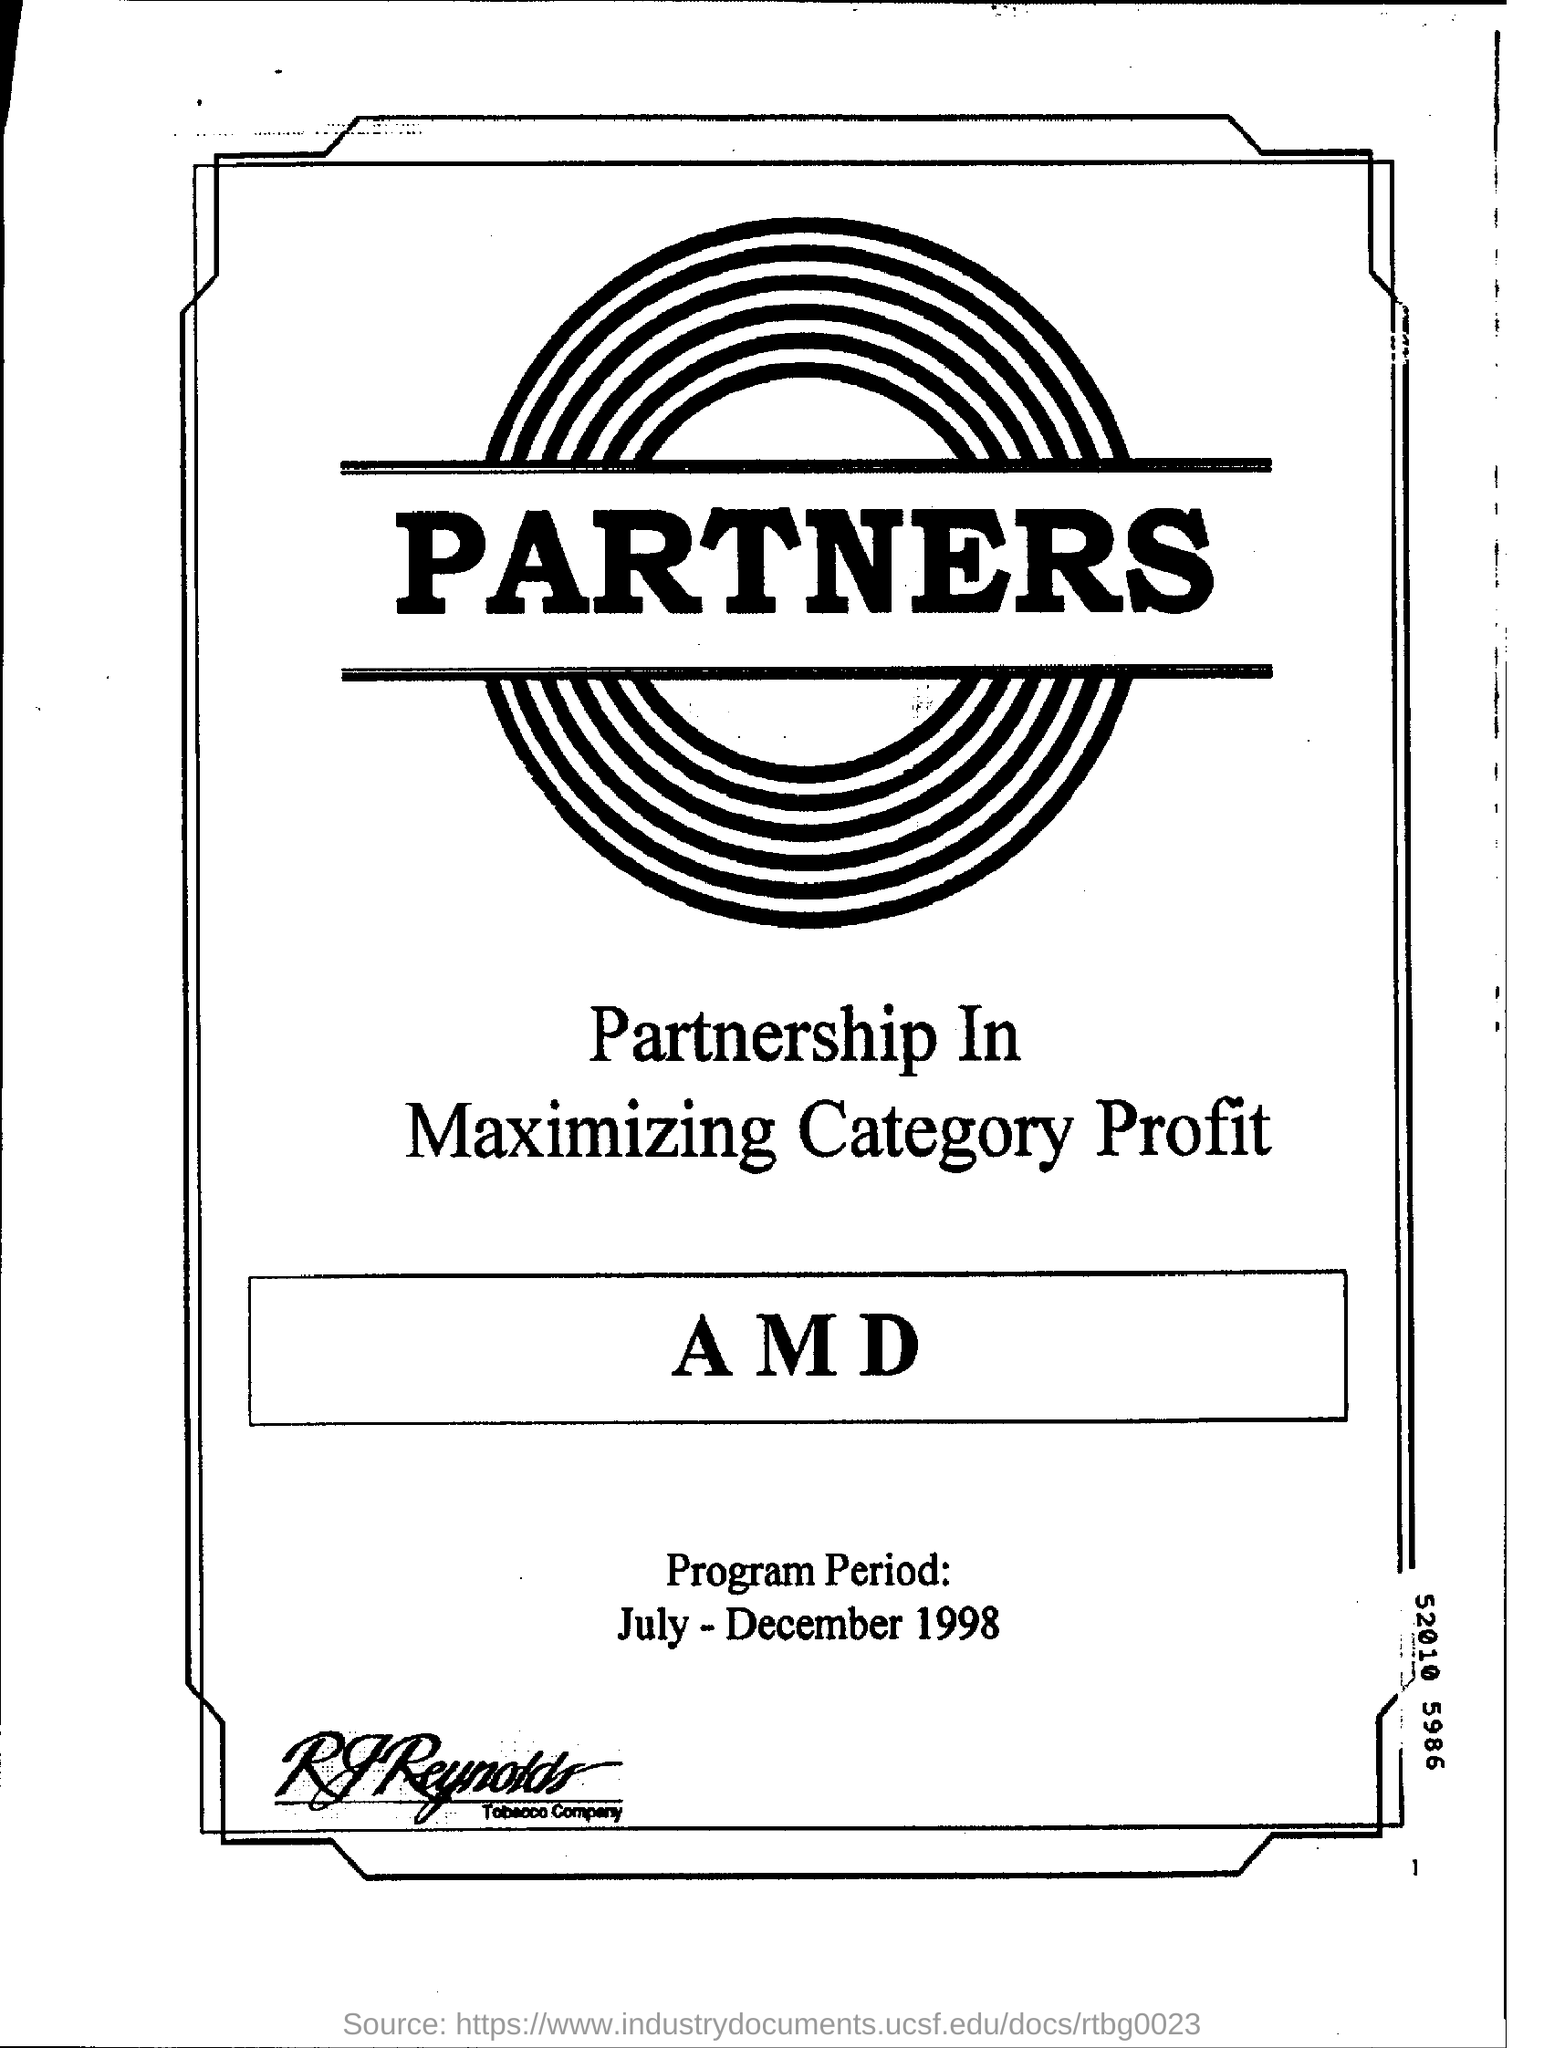Mention a couple of crucial points in this snapshot. The program's implementation period was from July to December 1998. 